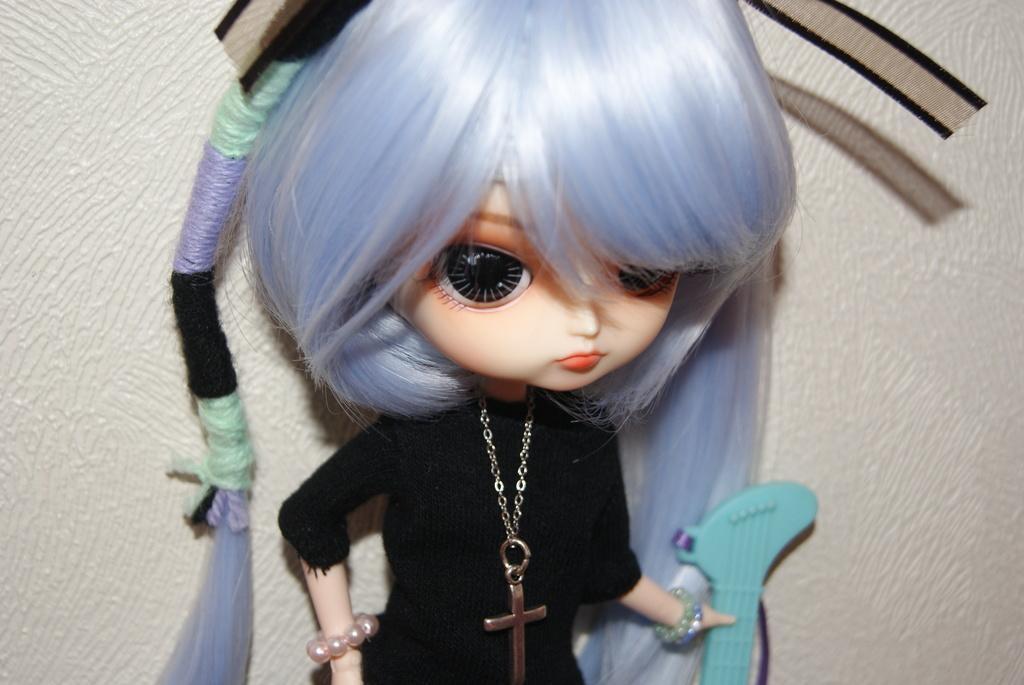Please provide a concise description of this image. In the image we can see a doll wearing clothes and bracelet, this is a chain and a cross mark, and the doll is holding an object in hand. 